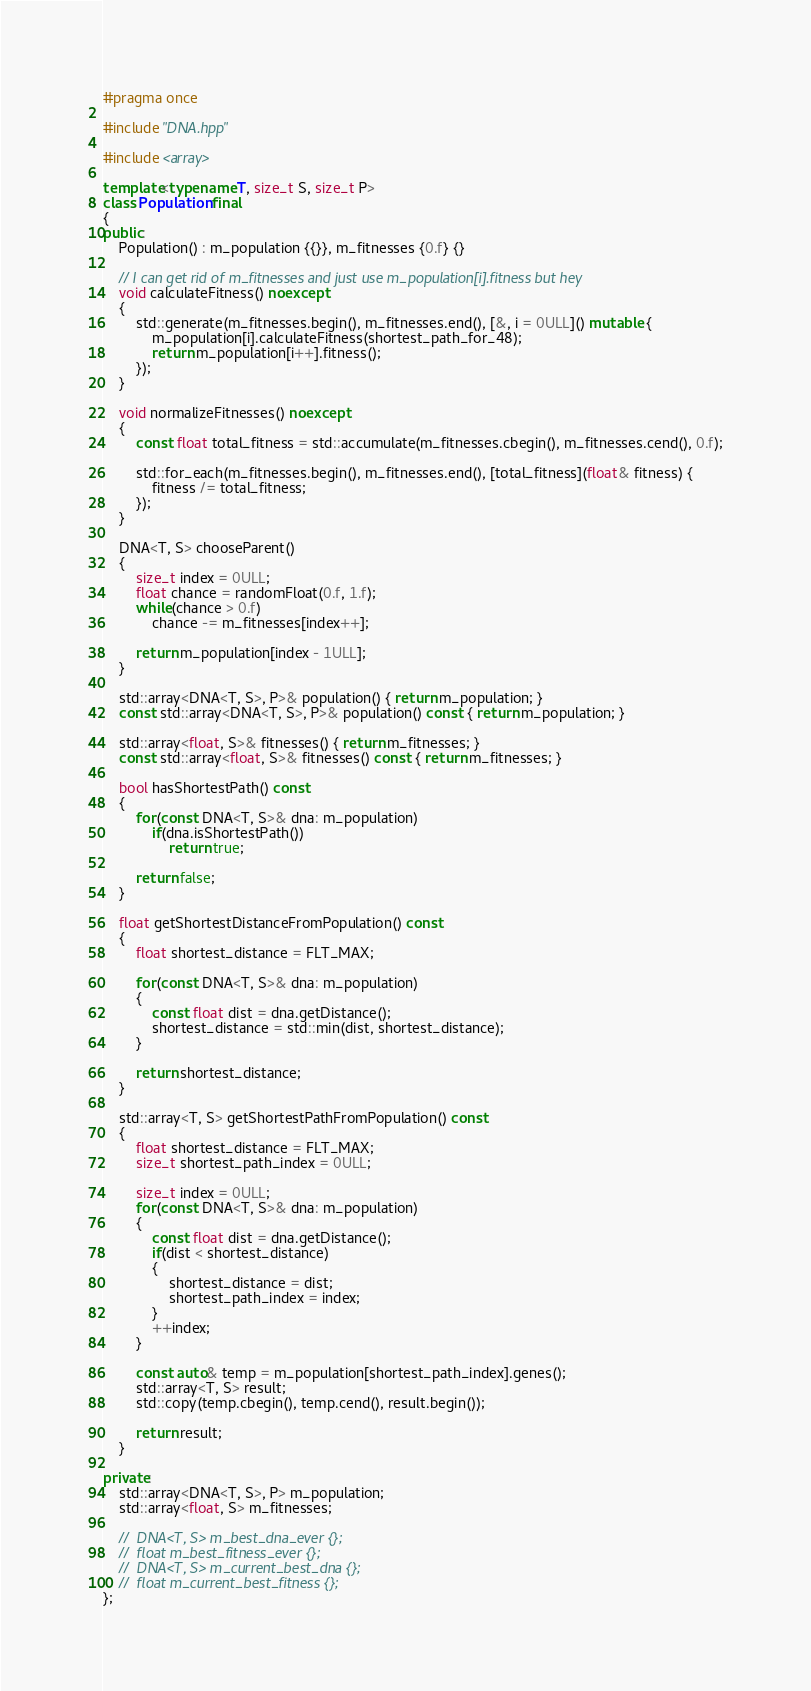<code> <loc_0><loc_0><loc_500><loc_500><_C++_>#pragma once

#include "DNA.hpp"

#include <array>

template<typename T, size_t S, size_t P>
class Population final
{
public:
	Population() : m_population {{}}, m_fitnesses {0.f} {}

	// I can get rid of m_fitnesses and just use m_population[i].fitness but hey
	void calculateFitness() noexcept
	{
		std::generate(m_fitnesses.begin(), m_fitnesses.end(), [&, i = 0ULL]() mutable {
			m_population[i].calculateFitness(shortest_path_for_48);
			return m_population[i++].fitness();
		});
	}

	void normalizeFitnesses() noexcept
	{
		const float total_fitness = std::accumulate(m_fitnesses.cbegin(), m_fitnesses.cend(), 0.f);

		std::for_each(m_fitnesses.begin(), m_fitnesses.end(), [total_fitness](float& fitness) {
			fitness /= total_fitness;
		});
	}

	DNA<T, S> chooseParent()
	{
		size_t index = 0ULL;
		float chance = randomFloat(0.f, 1.f);
		while(chance > 0.f)
			chance -= m_fitnesses[index++];

		return m_population[index - 1ULL];
	}

	std::array<DNA<T, S>, P>& population() { return m_population; }
	const std::array<DNA<T, S>, P>& population() const { return m_population; }

	std::array<float, S>& fitnesses() { return m_fitnesses; }
	const std::array<float, S>& fitnesses() const { return m_fitnesses; }

	bool hasShortestPath() const
	{
		for(const DNA<T, S>& dna: m_population)
			if(dna.isShortestPath())
				return true;

		return false;
	}

	float getShortestDistanceFromPopulation() const
	{
		float shortest_distance = FLT_MAX;

		for(const DNA<T, S>& dna: m_population)
		{
			const float dist = dna.getDistance();
			shortest_distance = std::min(dist, shortest_distance);
		}

		return shortest_distance;
	}

	std::array<T, S> getShortestPathFromPopulation() const
	{
		float shortest_distance = FLT_MAX;
		size_t shortest_path_index = 0ULL;

		size_t index = 0ULL;
		for(const DNA<T, S>& dna: m_population)
		{
			const float dist = dna.getDistance();
			if(dist < shortest_distance)
			{
				shortest_distance = dist;
				shortest_path_index = index;
			}
			++index;
		}

		const auto& temp = m_population[shortest_path_index].genes();
		std::array<T, S> result;
		std::copy(temp.cbegin(), temp.cend(), result.begin());

		return result;
	}

private:
	std::array<DNA<T, S>, P> m_population;
	std::array<float, S> m_fitnesses;

	//	DNA<T, S> m_best_dna_ever {};
	//	float m_best_fitness_ever {};
	//	DNA<T, S> m_current_best_dna {};
	//	float m_current_best_fitness {};
};
</code> 